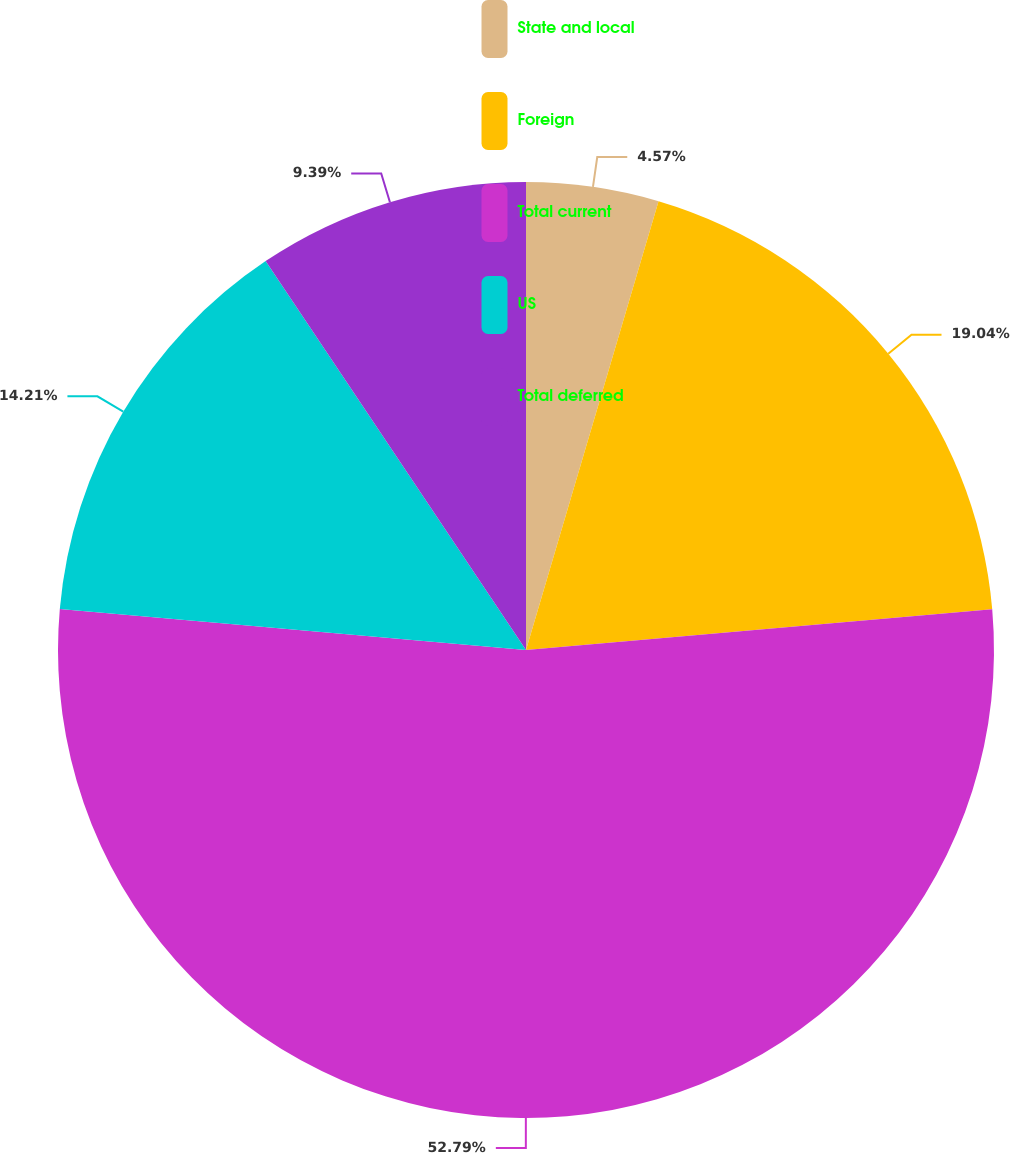<chart> <loc_0><loc_0><loc_500><loc_500><pie_chart><fcel>State and local<fcel>Foreign<fcel>Total current<fcel>US<fcel>Total deferred<nl><fcel>4.57%<fcel>19.04%<fcel>52.79%<fcel>14.21%<fcel>9.39%<nl></chart> 